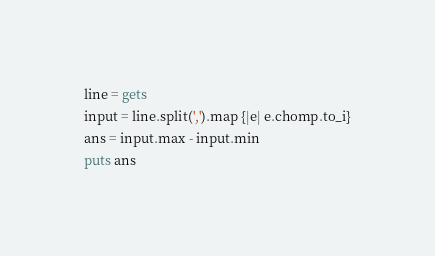<code> <loc_0><loc_0><loc_500><loc_500><_Ruby_>line = gets
input = line.split(',').map {|e| e.chomp.to_i}
ans = input.max - input.min
puts ans</code> 